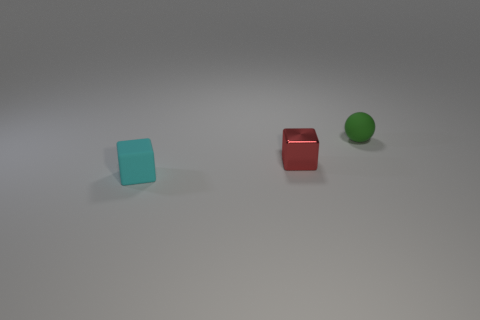The rubber cube has what size?
Your answer should be compact. Small. Do the green ball and the rubber object that is in front of the small ball have the same size?
Provide a short and direct response. Yes. How many brown objects are shiny objects or blocks?
Ensure brevity in your answer.  0. How many small metallic blocks are there?
Ensure brevity in your answer.  1. There is a rubber thing left of the small sphere; what is its size?
Your answer should be very brief. Small. Does the red block have the same size as the cyan rubber cube?
Provide a short and direct response. Yes. What number of objects are small matte spheres or small objects in front of the small green matte ball?
Make the answer very short. 3. What is the tiny red block made of?
Ensure brevity in your answer.  Metal. Are there any other things that have the same color as the shiny cube?
Your answer should be very brief. No. Is the small cyan rubber thing the same shape as the red object?
Provide a short and direct response. Yes. 